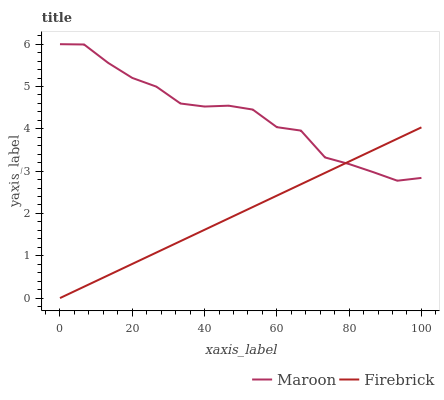Does Firebrick have the minimum area under the curve?
Answer yes or no. Yes. Does Maroon have the maximum area under the curve?
Answer yes or no. Yes. Does Maroon have the minimum area under the curve?
Answer yes or no. No. Is Firebrick the smoothest?
Answer yes or no. Yes. Is Maroon the roughest?
Answer yes or no. Yes. Is Maroon the smoothest?
Answer yes or no. No. Does Firebrick have the lowest value?
Answer yes or no. Yes. Does Maroon have the lowest value?
Answer yes or no. No. Does Maroon have the highest value?
Answer yes or no. Yes. Does Firebrick intersect Maroon?
Answer yes or no. Yes. Is Firebrick less than Maroon?
Answer yes or no. No. Is Firebrick greater than Maroon?
Answer yes or no. No. 